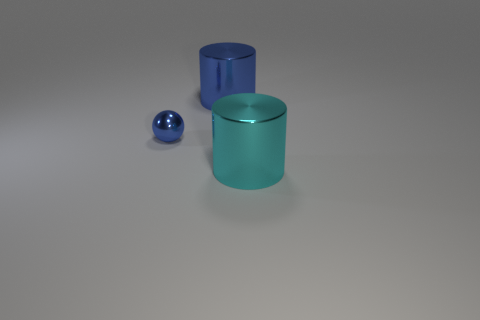Does the cyan metallic thing have the same size as the blue object to the right of the small metallic sphere?
Provide a succinct answer. Yes. What is the material of the large thing that is behind the tiny blue metallic object?
Your answer should be very brief. Metal. Are there an equal number of big cyan shiny cylinders behind the small blue ball and big brown matte objects?
Your response must be concise. Yes. Do the cyan shiny thing and the shiny sphere have the same size?
Provide a short and direct response. No. There is a large metallic object behind the big thing on the right side of the large blue metallic object; are there any small blue metallic balls behind it?
Provide a succinct answer. No. There is a large blue object that is the same shape as the big cyan object; what is it made of?
Provide a succinct answer. Metal. There is a thing in front of the small object; how many big metal things are left of it?
Your answer should be compact. 1. There is a shiny cylinder that is to the right of the large object to the left of the big cyan metal cylinder to the right of the big blue shiny object; what size is it?
Your answer should be very brief. Large. What is the color of the large cylinder behind the thing that is in front of the small ball?
Offer a very short reply. Blue. How many other things are there of the same material as the large blue cylinder?
Offer a very short reply. 2. 